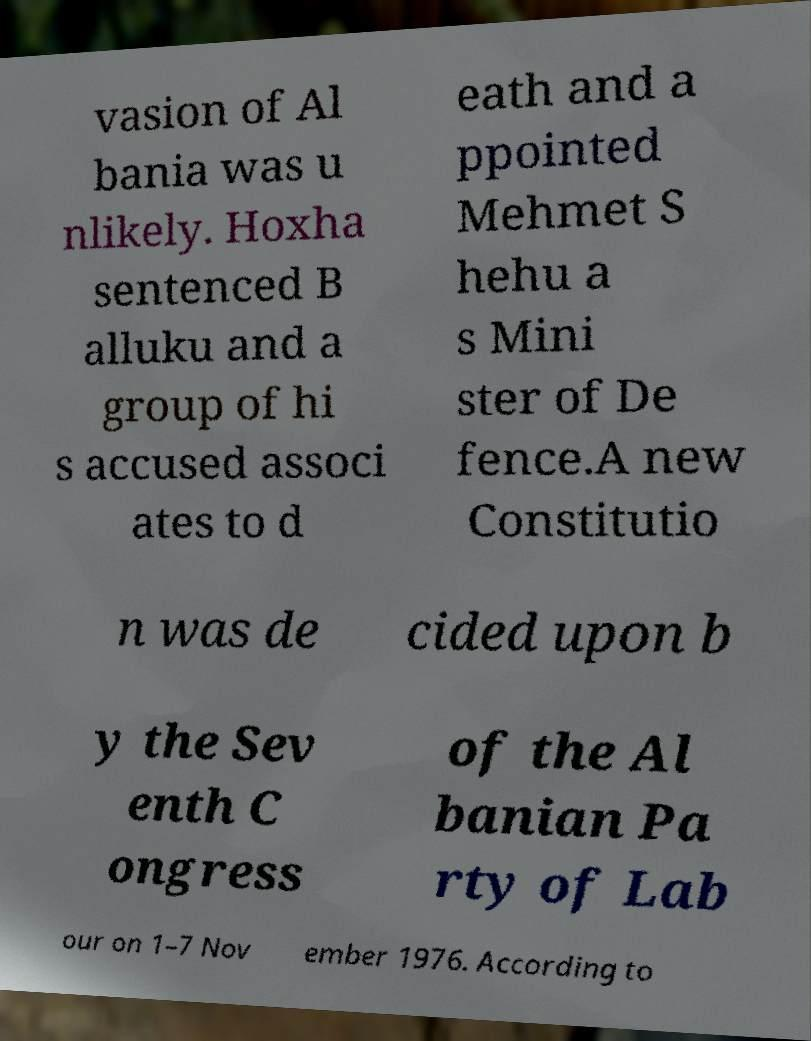Please read and relay the text visible in this image. What does it say? vasion of Al bania was u nlikely. Hoxha sentenced B alluku and a group of hi s accused associ ates to d eath and a ppointed Mehmet S hehu a s Mini ster of De fence.A new Constitutio n was de cided upon b y the Sev enth C ongress of the Al banian Pa rty of Lab our on 1–7 Nov ember 1976. According to 